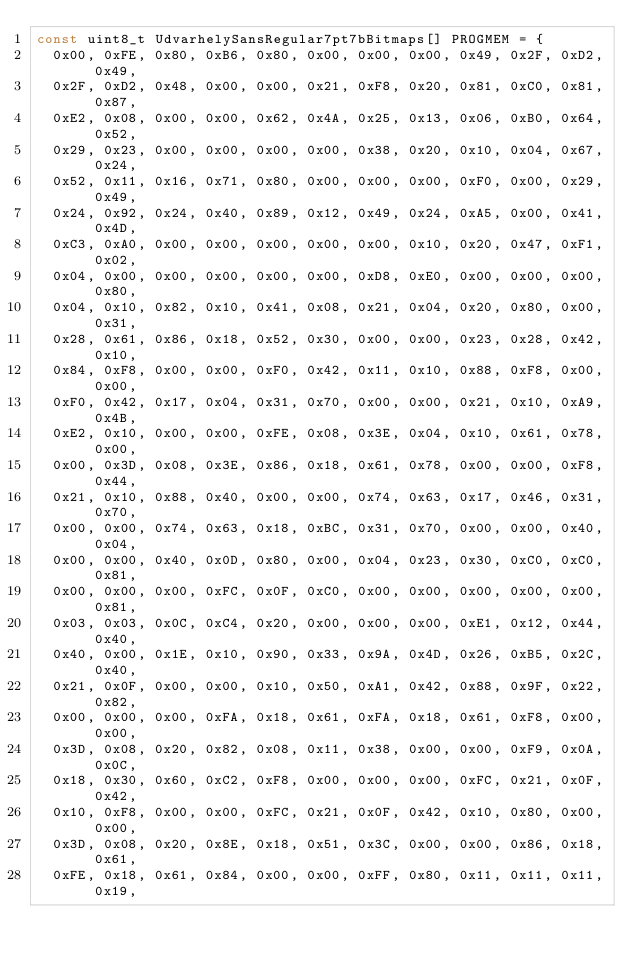<code> <loc_0><loc_0><loc_500><loc_500><_C_>const uint8_t UdvarhelySansRegular7pt7bBitmaps[] PROGMEM = {
  0x00, 0xFE, 0x80, 0xB6, 0x80, 0x00, 0x00, 0x00, 0x49, 0x2F, 0xD2, 0x49,
  0x2F, 0xD2, 0x48, 0x00, 0x00, 0x21, 0xF8, 0x20, 0x81, 0xC0, 0x81, 0x87,
  0xE2, 0x08, 0x00, 0x00, 0x62, 0x4A, 0x25, 0x13, 0x06, 0xB0, 0x64, 0x52,
  0x29, 0x23, 0x00, 0x00, 0x00, 0x00, 0x38, 0x20, 0x10, 0x04, 0x67, 0x24,
  0x52, 0x11, 0x16, 0x71, 0x80, 0x00, 0x00, 0x00, 0xF0, 0x00, 0x29, 0x49,
  0x24, 0x92, 0x24, 0x40, 0x89, 0x12, 0x49, 0x24, 0xA5, 0x00, 0x41, 0x4D,
  0xC3, 0xA0, 0x00, 0x00, 0x00, 0x00, 0x00, 0x10, 0x20, 0x47, 0xF1, 0x02,
  0x04, 0x00, 0x00, 0x00, 0x00, 0x00, 0xD8, 0xE0, 0x00, 0x00, 0x00, 0x80,
  0x04, 0x10, 0x82, 0x10, 0x41, 0x08, 0x21, 0x04, 0x20, 0x80, 0x00, 0x31,
  0x28, 0x61, 0x86, 0x18, 0x52, 0x30, 0x00, 0x00, 0x23, 0x28, 0x42, 0x10,
  0x84, 0xF8, 0x00, 0x00, 0xF0, 0x42, 0x11, 0x10, 0x88, 0xF8, 0x00, 0x00,
  0xF0, 0x42, 0x17, 0x04, 0x31, 0x70, 0x00, 0x00, 0x21, 0x10, 0xA9, 0x4B,
  0xE2, 0x10, 0x00, 0x00, 0xFE, 0x08, 0x3E, 0x04, 0x10, 0x61, 0x78, 0x00,
  0x00, 0x3D, 0x08, 0x3E, 0x86, 0x18, 0x61, 0x78, 0x00, 0x00, 0xF8, 0x44,
  0x21, 0x10, 0x88, 0x40, 0x00, 0x00, 0x74, 0x63, 0x17, 0x46, 0x31, 0x70,
  0x00, 0x00, 0x74, 0x63, 0x18, 0xBC, 0x31, 0x70, 0x00, 0x00, 0x40, 0x04,
  0x00, 0x00, 0x40, 0x0D, 0x80, 0x00, 0x04, 0x23, 0x30, 0xC0, 0xC0, 0x81,
  0x00, 0x00, 0x00, 0xFC, 0x0F, 0xC0, 0x00, 0x00, 0x00, 0x00, 0x00, 0x81,
  0x03, 0x03, 0x0C, 0xC4, 0x20, 0x00, 0x00, 0x00, 0xE1, 0x12, 0x44, 0x40,
  0x40, 0x00, 0x1E, 0x10, 0x90, 0x33, 0x9A, 0x4D, 0x26, 0xB5, 0x2C, 0x40,
  0x21, 0x0F, 0x00, 0x00, 0x10, 0x50, 0xA1, 0x42, 0x88, 0x9F, 0x22, 0x82,
  0x00, 0x00, 0x00, 0xFA, 0x18, 0x61, 0xFA, 0x18, 0x61, 0xF8, 0x00, 0x00,
  0x3D, 0x08, 0x20, 0x82, 0x08, 0x11, 0x38, 0x00, 0x00, 0xF9, 0x0A, 0x0C,
  0x18, 0x30, 0x60, 0xC2, 0xF8, 0x00, 0x00, 0x00, 0xFC, 0x21, 0x0F, 0x42,
  0x10, 0xF8, 0x00, 0x00, 0xFC, 0x21, 0x0F, 0x42, 0x10, 0x80, 0x00, 0x00,
  0x3D, 0x08, 0x20, 0x8E, 0x18, 0x51, 0x3C, 0x00, 0x00, 0x86, 0x18, 0x61,
  0xFE, 0x18, 0x61, 0x84, 0x00, 0x00, 0xFF, 0x80, 0x11, 0x11, 0x11, 0x19,</code> 